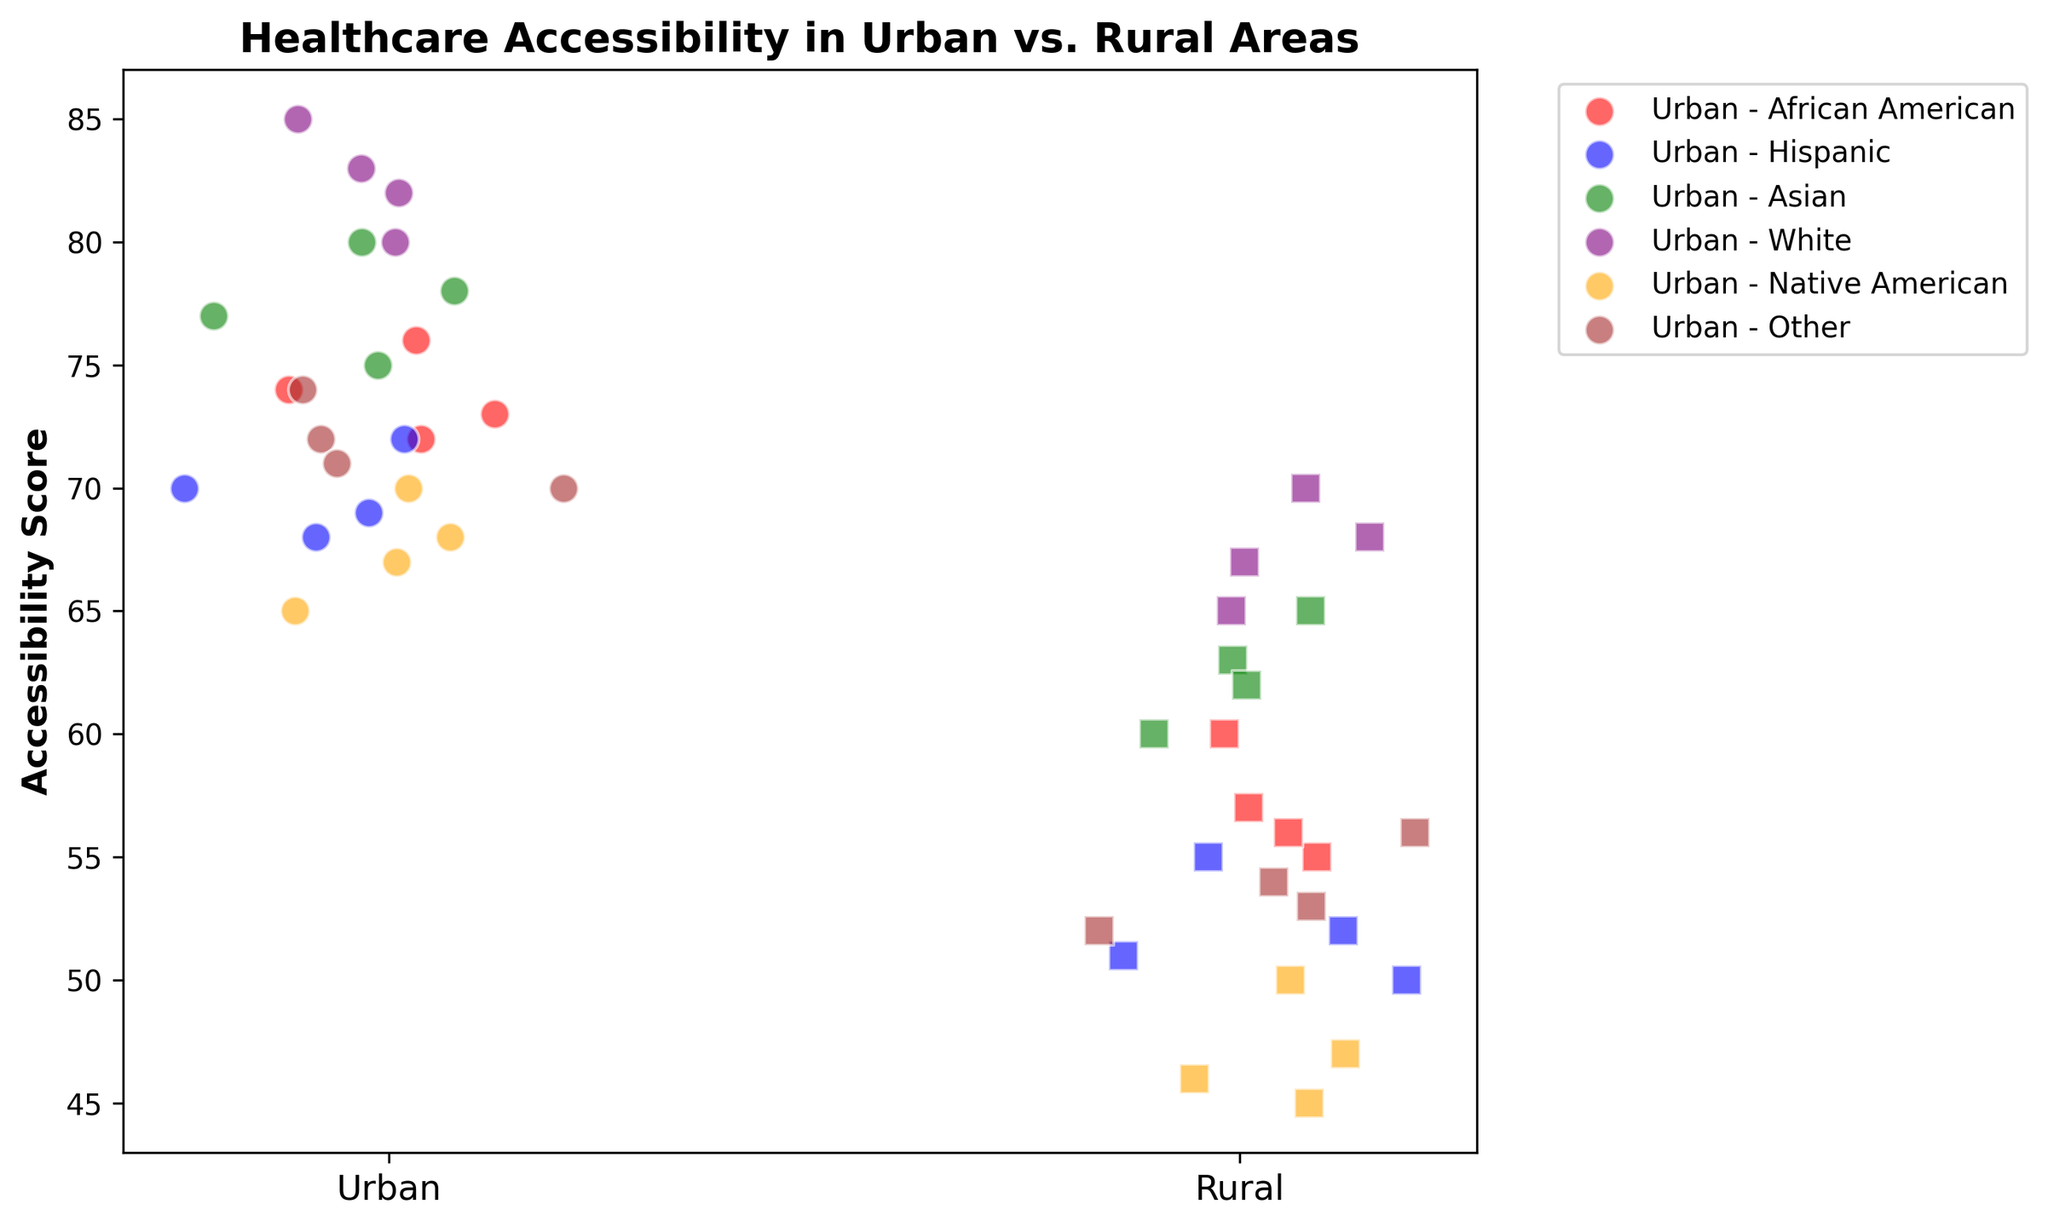How do the accessibility scores of African Americans in urban areas compare to those in rural areas? Look at the clusters for African Americans in urban areas (plotted with red circles) and in rural areas (plotted with red squares). The scores in urban areas are in the 70s, while in rural areas, the scores are in the 50s and 60s.
Answer: Higher in Urban Which demographic has the highest average accessibility score in urban areas? Identify the plot points for each demographic in urban areas, calculate the average for each, and compare them. For whites, the scores range from 80 to 85, making it the highest average.
Answer: Whites By approximately how much do the accessibility scores for the Hispanic demographic differ between urban and rural areas? Compare the scores of Hispanics between urban (blue circles) and rural (blue squares). Urban scores are around 68-72, and rural scores are around 50-55. The difference is roughly 17-20 points.
Answer: 17-20 points Are there any demographics for which the accessibility scores in rural areas are higher than in urban areas? Compare individual scores in rural and urban areas. None of the rural scores exceed the corresponding urban scores for any demographic.
Answer: No Which demographic group displays the widest range of accessibility scores in urban areas? Check the spread of the scores for each demographic in urban areas. Native Americans have scores from 65 to 70, which is the widest range.
Answer: Native Americans Compare the average accessibility score of Asian demographics in both urban and rural areas. Calculate the average score for Asians in urban areas (75, 78, 80, 77) and rural areas (60, 63, 65, 62). Urban average is around 77.5 and rural average is around 62.5.
Answer: Urban: 77.5, Rural: 62.5 What can be observed about the native American demographic in both settings? For Native Americans, urban scores vary from 65 to 70, while rural scores range from 45 to 50. Both clusters show that urban scores are higher.
Answer: Urban higher Among the rural demographics, which has the lowest accessibility score? Look at rural scores, and identify the lowest value. Native Americans have the lowest with 45-50.
Answer: Native Americans How does the accessibility score for the "Other" demographic in rural areas compare to the other rural scores? "Other" in rural areas (brown squares) ranges from 52 to 56, placed in the middle among the rural scores.
Answer: Middle How does the distribution of accessibility scores in urban areas compare visually to those in rural areas? Urban areas show higher and more clustered scores, while rural areas show lower and more spread-out scores.
Answer: Urban: clustered, higher; Rural: spread-out, lower 